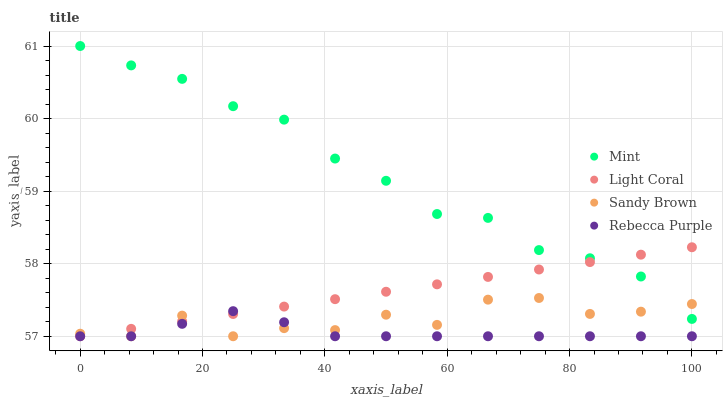Does Rebecca Purple have the minimum area under the curve?
Answer yes or no. Yes. Does Mint have the maximum area under the curve?
Answer yes or no. Yes. Does Sandy Brown have the minimum area under the curve?
Answer yes or no. No. Does Sandy Brown have the maximum area under the curve?
Answer yes or no. No. Is Light Coral the smoothest?
Answer yes or no. Yes. Is Sandy Brown the roughest?
Answer yes or no. Yes. Is Mint the smoothest?
Answer yes or no. No. Is Mint the roughest?
Answer yes or no. No. Does Light Coral have the lowest value?
Answer yes or no. Yes. Does Mint have the lowest value?
Answer yes or no. No. Does Mint have the highest value?
Answer yes or no. Yes. Does Sandy Brown have the highest value?
Answer yes or no. No. Is Rebecca Purple less than Mint?
Answer yes or no. Yes. Is Mint greater than Rebecca Purple?
Answer yes or no. Yes. Does Light Coral intersect Sandy Brown?
Answer yes or no. Yes. Is Light Coral less than Sandy Brown?
Answer yes or no. No. Is Light Coral greater than Sandy Brown?
Answer yes or no. No. Does Rebecca Purple intersect Mint?
Answer yes or no. No. 